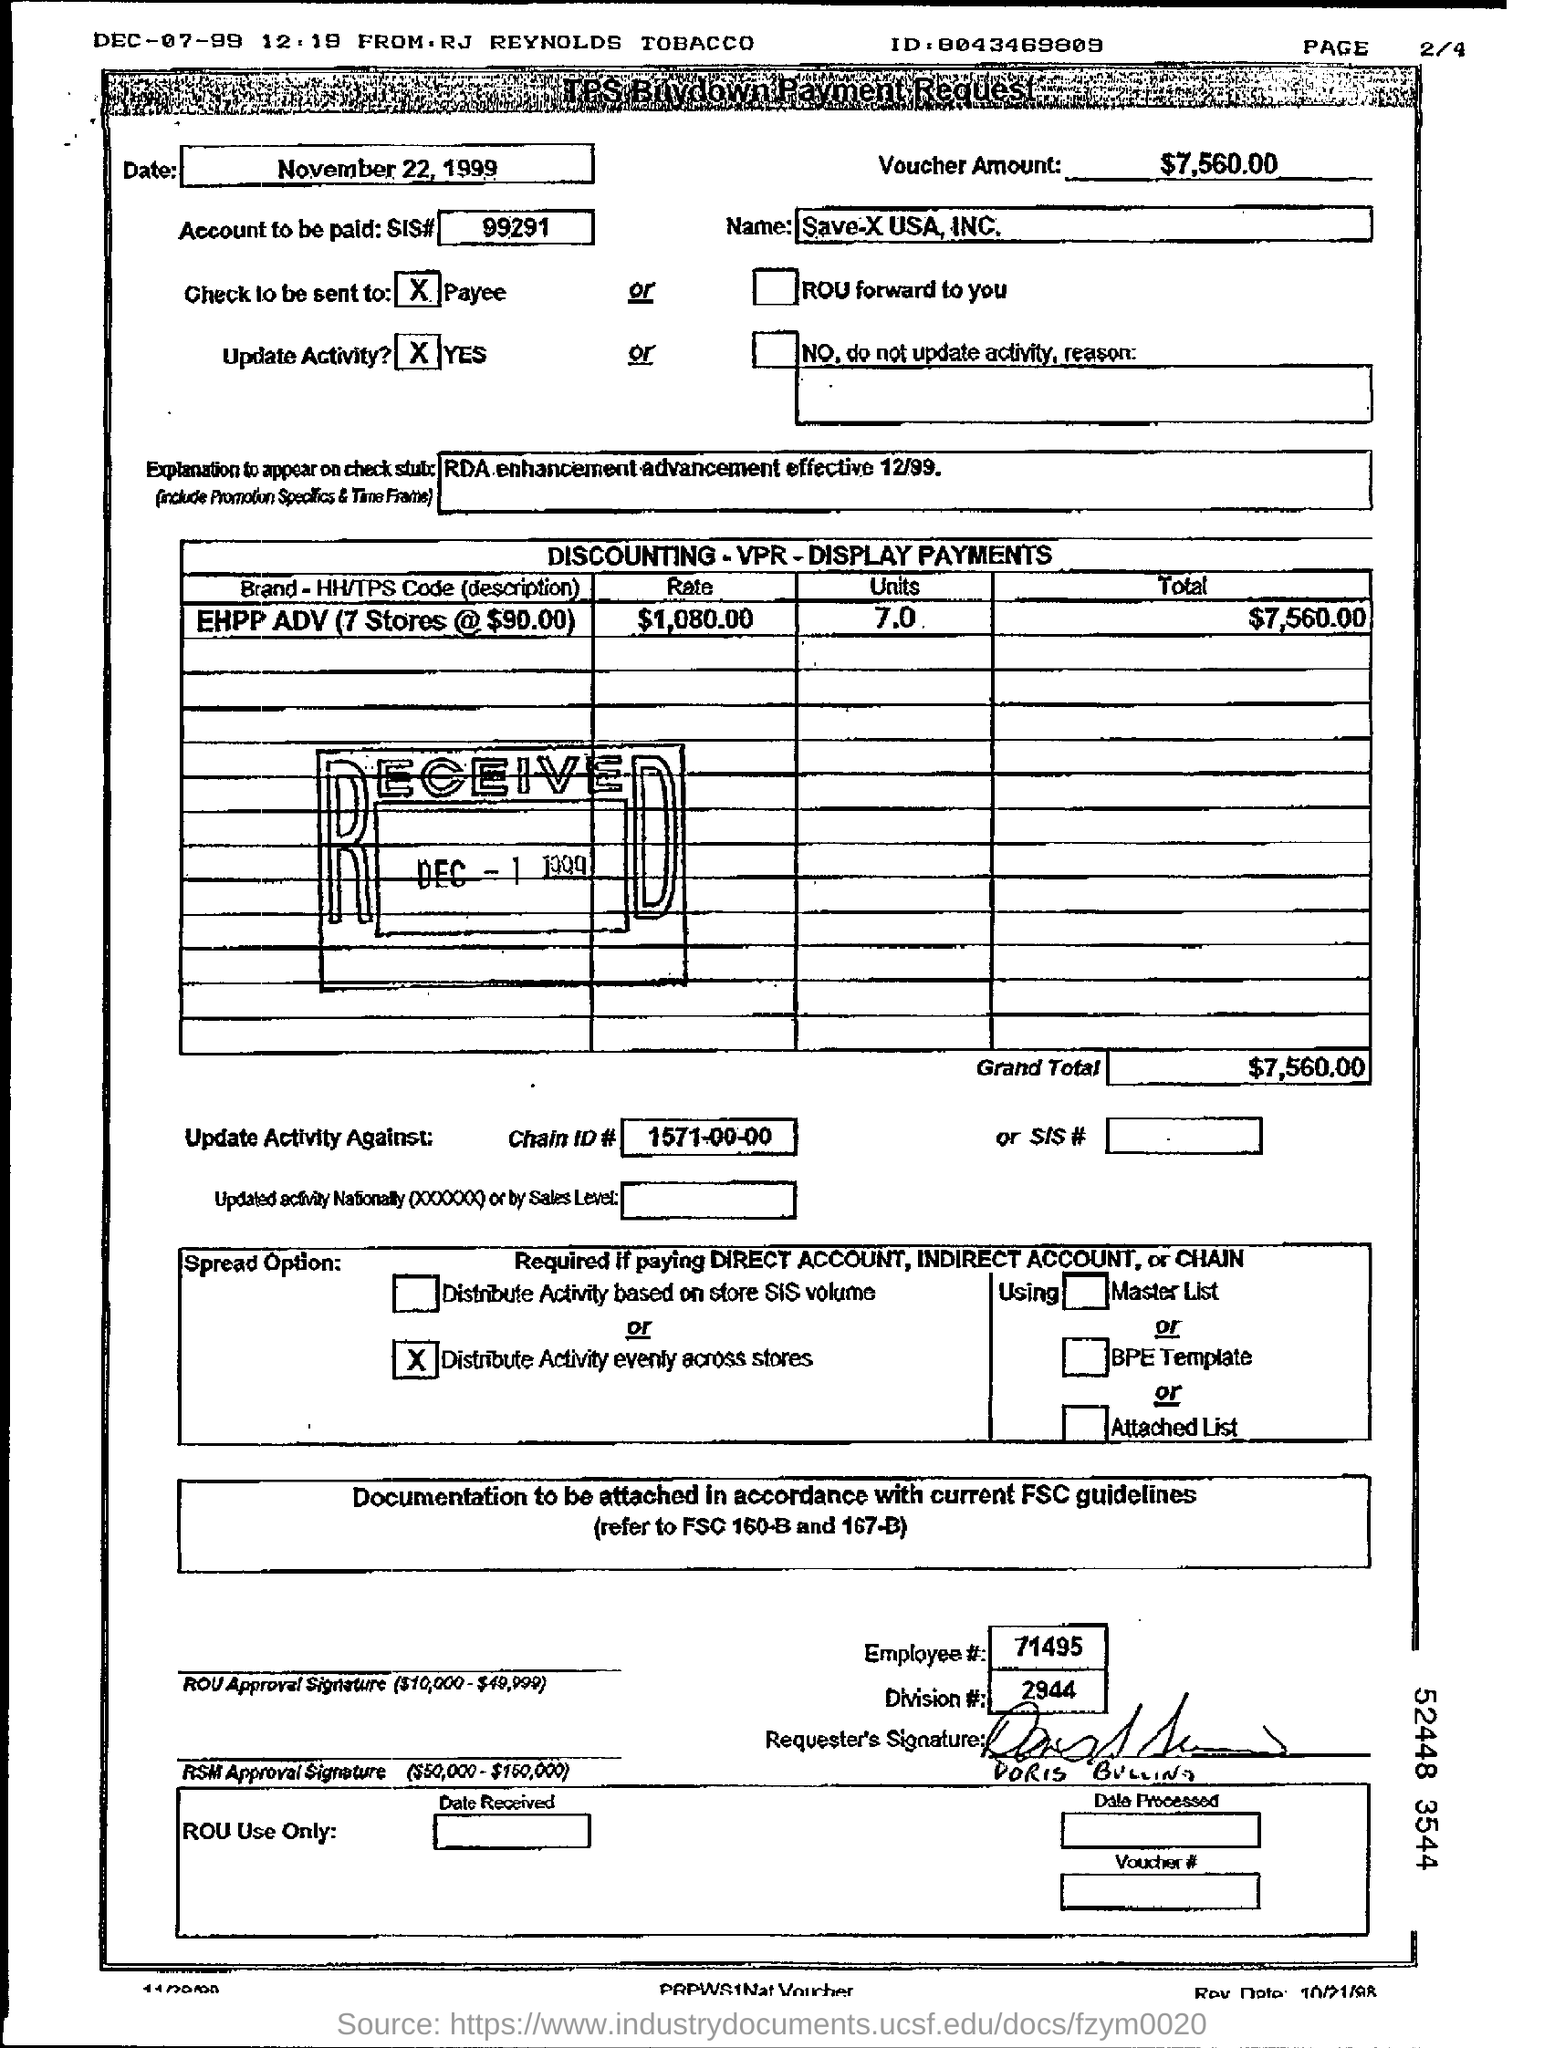what is the brand - HH/TPS code (description)? The brand referred to as 'EHPP ADV' pertains to a payment agreement involving 7 stores, each charged at $90.00. This detail suggests a commercial arrangement possibly involving special advertising or product placement across these locations. The total cost amounts to $7,560.00. 